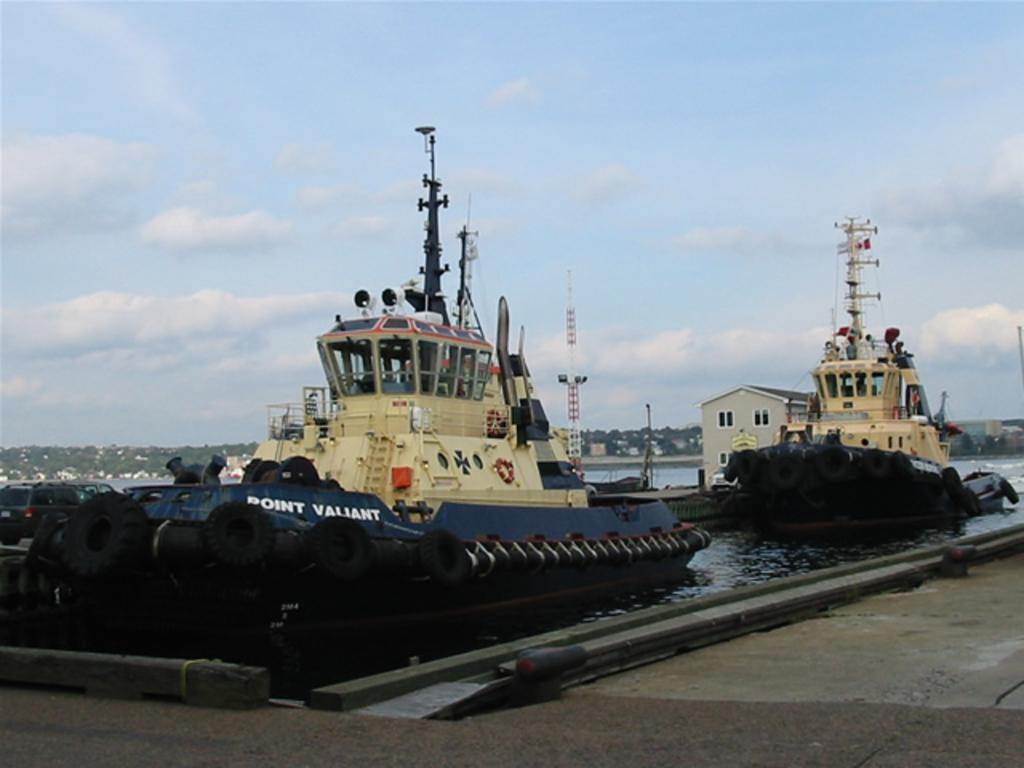What objects related to transportation can be seen in the image? There are tyres and swim tubes in the image. What type of structure is present in the image? There is a tower in the image. What are the poles used for in the image? The purpose of the poles is not specified in the image. Can you describe the house in the image? The house has windows and is located in the image. What is happening on the water in the image? There are ships on water in the image. What is the path used for in the image? The purpose of the path is not specified in the image. What type of vegetation is present in the image? There are trees in the image. What is visible in the background of the image? The sky with clouds is visible in the background of the image. What activity is the brother participating in with the grip in the image? There is no mention of a brother or a grip in the image. 